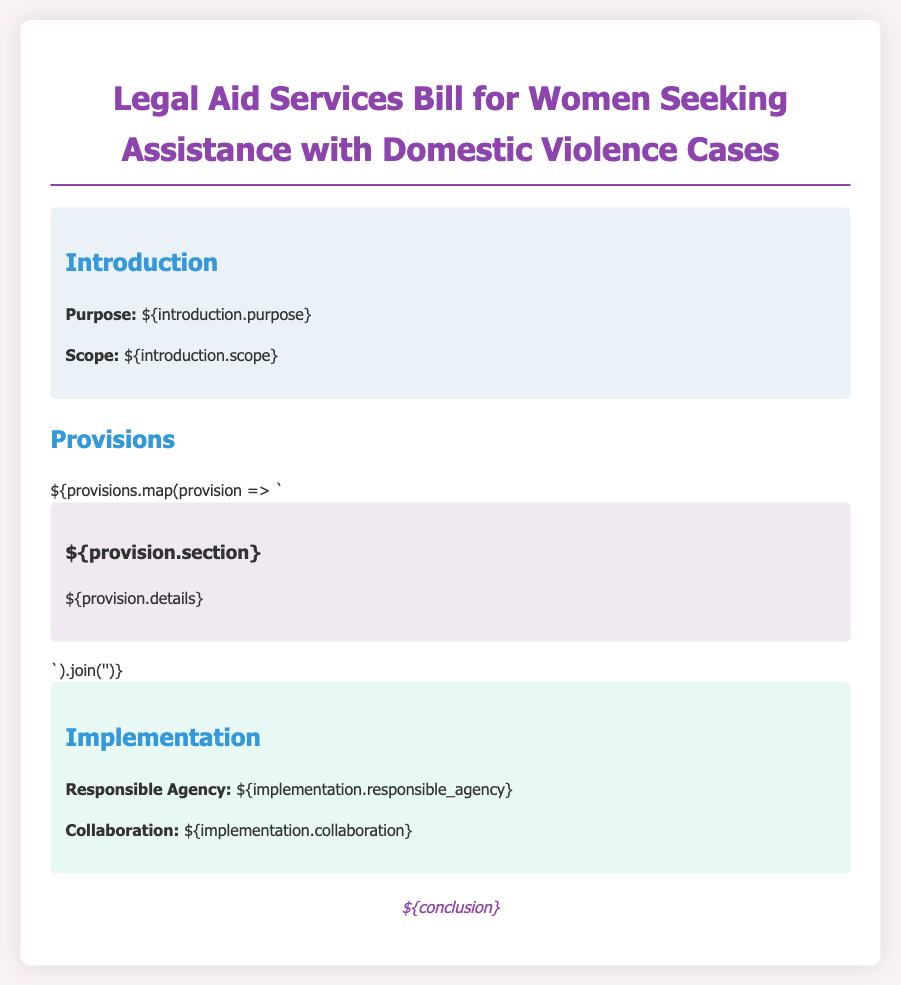What is the purpose of the bill? The purpose of the bill explains the main objective of the document regarding legal aid services.
Answer: Women's empowerment What agency is responsible for the implementation? This information outlines which organization or agency will be in charge of executing the provisions of the bill.
Answer: Responsible Agency What does the scope of the bill cover? The scope details the areas and situations that the bill addresses concerning domestic violence and legal aid.
Answer: Assistance with domestic violence cases How are consultation fees addressed in the bill? This question focuses on what the bill states regarding the costs of consultations for women seeking aid.
Answer: Detailed in provisions What collaborations are mentioned for implementation? This looks for the cooperative efforts listed in the bill for successful implementation.
Answer: Collaboration How many sections are included in the provisions? This requires counting the number of distinct sections outlined in the provisions of the bill.
Answer: Number of sections What type of assistance does this bill primarily focus on? This question requests the primary aim of the bill regarding the kind of support it aims to provide.
Answer: Legal aid services What is emphasized in the conclusion of the bill? The conclusion summarizes the overarching message or call to action stated at the end of the bill.
Answer: Legal support What color is used in the document's heading? This question asks for the specific color associated with the heading of the bill in the rendered document.
Answer: Purple 